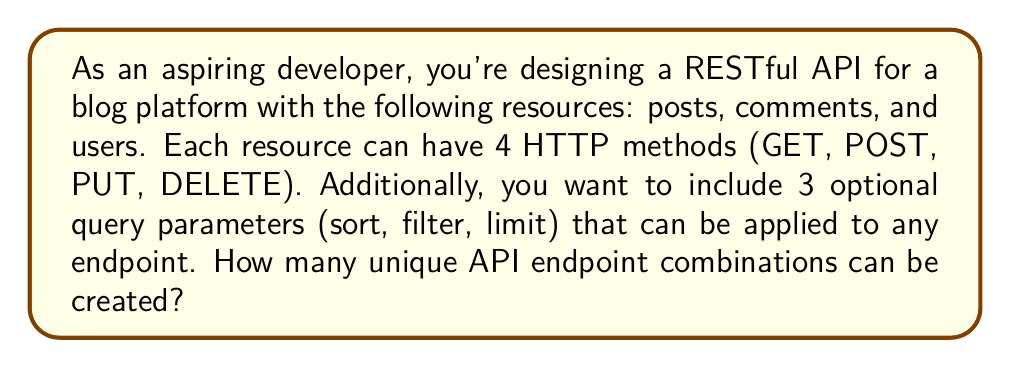Give your solution to this math problem. Let's break this down step-by-step:

1. First, we need to calculate the number of possible resource-method combinations:
   - Number of resources: 3 (posts, comments, users)
   - Number of HTTP methods: 4 (GET, POST, PUT, DELETE)
   - Total resource-method combinations: $3 \times 4 = 12$

2. Now, we need to consider the optional query parameters:
   - Number of query parameters: 3 (sort, filter, limit)
   - Each parameter can be either present or absent
   - This creates $2^3 = 8$ possible combinations of query parameters

3. For each resource-method combination, we can have any of the 8 query parameter combinations:
   - Total unique endpoint combinations: $12 \times 8 = 96$

4. We can express this mathematically as:

   $$\text{Total combinations} = (\text{resources} \times \text{methods}) \times 2^{\text{query parameters}}$$
   
   $$= (3 \times 4) \times 2^3 = 12 \times 8 = 96$$

Thus, there are 96 unique API endpoint combinations possible for this RESTful service.
Answer: 96 